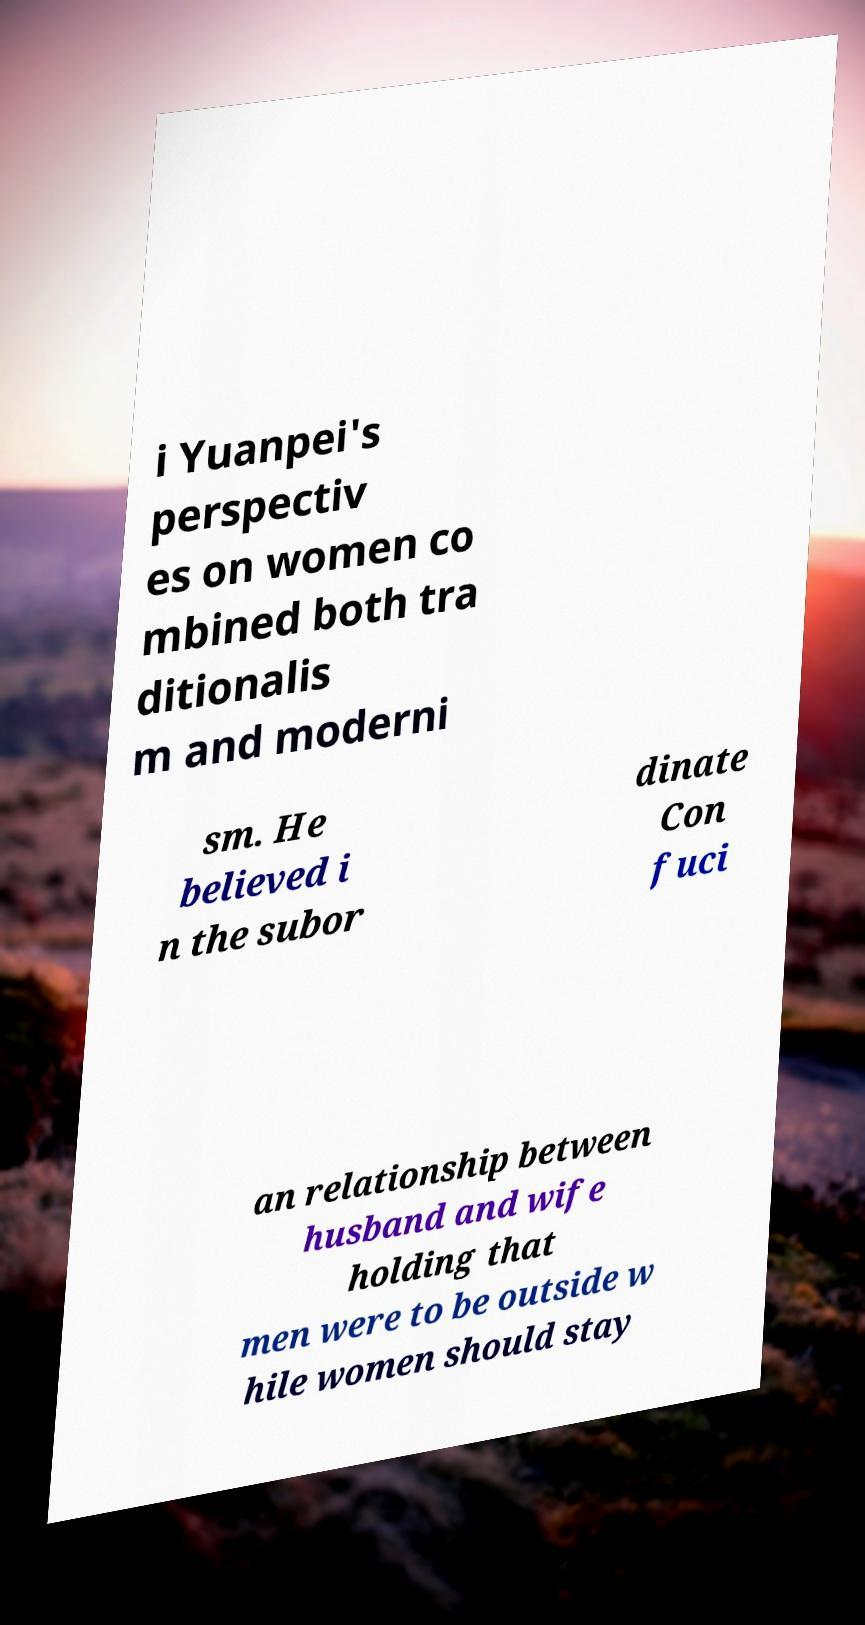Please read and relay the text visible in this image. What does it say? i Yuanpei's perspectiv es on women co mbined both tra ditionalis m and moderni sm. He believed i n the subor dinate Con fuci an relationship between husband and wife holding that men were to be outside w hile women should stay 